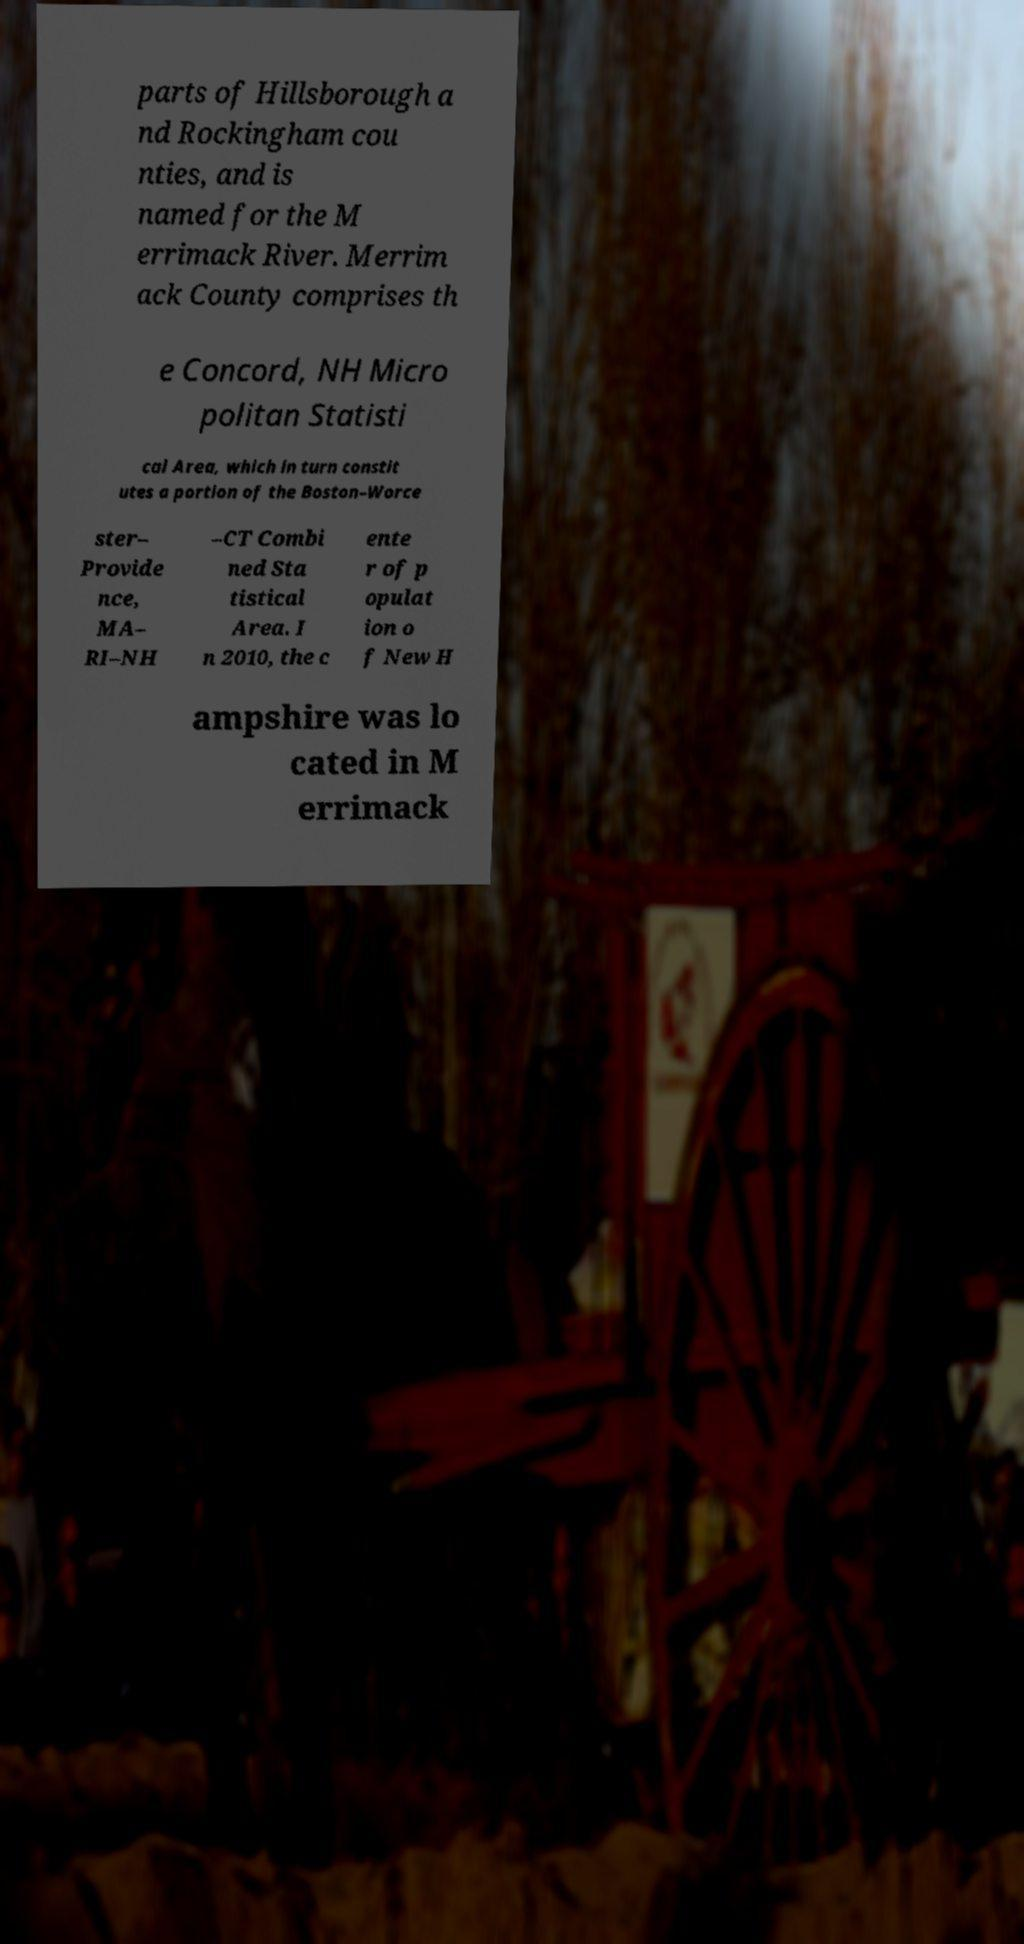Please read and relay the text visible in this image. What does it say? parts of Hillsborough a nd Rockingham cou nties, and is named for the M errimack River. Merrim ack County comprises th e Concord, NH Micro politan Statisti cal Area, which in turn constit utes a portion of the Boston–Worce ster– Provide nce, MA– RI–NH –CT Combi ned Sta tistical Area. I n 2010, the c ente r of p opulat ion o f New H ampshire was lo cated in M errimack 